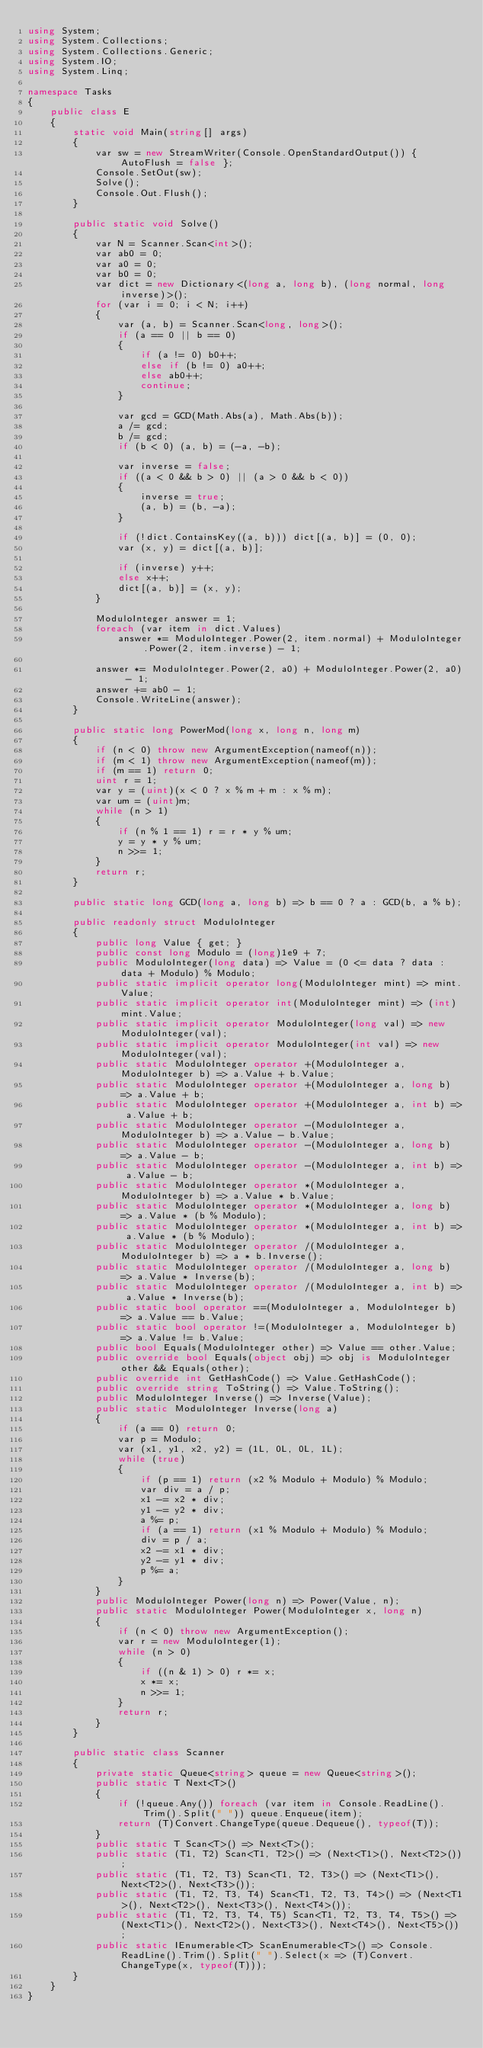Convert code to text. <code><loc_0><loc_0><loc_500><loc_500><_C#_>using System;
using System.Collections;
using System.Collections.Generic;
using System.IO;
using System.Linq;

namespace Tasks
{
    public class E
    {
        static void Main(string[] args)
        {
            var sw = new StreamWriter(Console.OpenStandardOutput()) { AutoFlush = false };
            Console.SetOut(sw);
            Solve();
            Console.Out.Flush();
        }

        public static void Solve()
        {
            var N = Scanner.Scan<int>();
            var ab0 = 0;
            var a0 = 0;
            var b0 = 0;
            var dict = new Dictionary<(long a, long b), (long normal, long inverse)>();
            for (var i = 0; i < N; i++)
            {
                var (a, b) = Scanner.Scan<long, long>();
                if (a == 0 || b == 0)
                {
                    if (a != 0) b0++;
                    else if (b != 0) a0++;
                    else ab0++;
                    continue;
                }

                var gcd = GCD(Math.Abs(a), Math.Abs(b));
                a /= gcd;
                b /= gcd;
                if (b < 0) (a, b) = (-a, -b);

                var inverse = false;
                if ((a < 0 && b > 0) || (a > 0 && b < 0))
                {
                    inverse = true;
                    (a, b) = (b, -a);
                }

                if (!dict.ContainsKey((a, b))) dict[(a, b)] = (0, 0);
                var (x, y) = dict[(a, b)];

                if (inverse) y++;
                else x++;
                dict[(a, b)] = (x, y);
            }

            ModuloInteger answer = 1;
            foreach (var item in dict.Values)
                answer *= ModuloInteger.Power(2, item.normal) + ModuloInteger.Power(2, item.inverse) - 1;

            answer *= ModuloInteger.Power(2, a0) + ModuloInteger.Power(2, a0) - 1;
            answer += ab0 - 1;
            Console.WriteLine(answer);
        }

        public static long PowerMod(long x, long n, long m)
        {
            if (n < 0) throw new ArgumentException(nameof(n));
            if (m < 1) throw new ArgumentException(nameof(m));
            if (m == 1) return 0;
            uint r = 1;
            var y = (uint)(x < 0 ? x % m + m : x % m);
            var um = (uint)m;
            while (n > 1)
            {
                if (n % 1 == 1) r = r * y % um;
                y = y * y % um;
                n >>= 1;
            }
            return r;
        }

        public static long GCD(long a, long b) => b == 0 ? a : GCD(b, a % b);

        public readonly struct ModuloInteger
        {
            public long Value { get; }
            public const long Modulo = (long)1e9 + 7;
            public ModuloInteger(long data) => Value = (0 <= data ? data : data + Modulo) % Modulo;
            public static implicit operator long(ModuloInteger mint) => mint.Value;
            public static implicit operator int(ModuloInteger mint) => (int)mint.Value;
            public static implicit operator ModuloInteger(long val) => new ModuloInteger(val);
            public static implicit operator ModuloInteger(int val) => new ModuloInteger(val);
            public static ModuloInteger operator +(ModuloInteger a, ModuloInteger b) => a.Value + b.Value;
            public static ModuloInteger operator +(ModuloInteger a, long b) => a.Value + b;
            public static ModuloInteger operator +(ModuloInteger a, int b) => a.Value + b;
            public static ModuloInteger operator -(ModuloInteger a, ModuloInteger b) => a.Value - b.Value;
            public static ModuloInteger operator -(ModuloInteger a, long b) => a.Value - b;
            public static ModuloInteger operator -(ModuloInteger a, int b) => a.Value - b;
            public static ModuloInteger operator *(ModuloInteger a, ModuloInteger b) => a.Value * b.Value;
            public static ModuloInteger operator *(ModuloInteger a, long b) => a.Value * (b % Modulo);
            public static ModuloInteger operator *(ModuloInteger a, int b) => a.Value * (b % Modulo);
            public static ModuloInteger operator /(ModuloInteger a, ModuloInteger b) => a * b.Inverse();
            public static ModuloInteger operator /(ModuloInteger a, long b) => a.Value * Inverse(b);
            public static ModuloInteger operator /(ModuloInteger a, int b) => a.Value * Inverse(b);
            public static bool operator ==(ModuloInteger a, ModuloInteger b) => a.Value == b.Value;
            public static bool operator !=(ModuloInteger a, ModuloInteger b) => a.Value != b.Value;
            public bool Equals(ModuloInteger other) => Value == other.Value;
            public override bool Equals(object obj) => obj is ModuloInteger other && Equals(other);
            public override int GetHashCode() => Value.GetHashCode();
            public override string ToString() => Value.ToString();
            public ModuloInteger Inverse() => Inverse(Value);
            public static ModuloInteger Inverse(long a)
            {
                if (a == 0) return 0;
                var p = Modulo;
                var (x1, y1, x2, y2) = (1L, 0L, 0L, 1L);
                while (true)
                {
                    if (p == 1) return (x2 % Modulo + Modulo) % Modulo;
                    var div = a / p;
                    x1 -= x2 * div;
                    y1 -= y2 * div;
                    a %= p;
                    if (a == 1) return (x1 % Modulo + Modulo) % Modulo;
                    div = p / a;
                    x2 -= x1 * div;
                    y2 -= y1 * div;
                    p %= a;
                }
            }
            public ModuloInteger Power(long n) => Power(Value, n);
            public static ModuloInteger Power(ModuloInteger x, long n)
            {
                if (n < 0) throw new ArgumentException();
                var r = new ModuloInteger(1);
                while (n > 0)
                {
                    if ((n & 1) > 0) r *= x;
                    x *= x;
                    n >>= 1;
                }
                return r;
            }
        }

        public static class Scanner
        {
            private static Queue<string> queue = new Queue<string>();
            public static T Next<T>()
            {
                if (!queue.Any()) foreach (var item in Console.ReadLine().Trim().Split(" ")) queue.Enqueue(item);
                return (T)Convert.ChangeType(queue.Dequeue(), typeof(T));
            }
            public static T Scan<T>() => Next<T>();
            public static (T1, T2) Scan<T1, T2>() => (Next<T1>(), Next<T2>());
            public static (T1, T2, T3) Scan<T1, T2, T3>() => (Next<T1>(), Next<T2>(), Next<T3>());
            public static (T1, T2, T3, T4) Scan<T1, T2, T3, T4>() => (Next<T1>(), Next<T2>(), Next<T3>(), Next<T4>());
            public static (T1, T2, T3, T4, T5) Scan<T1, T2, T3, T4, T5>() => (Next<T1>(), Next<T2>(), Next<T3>(), Next<T4>(), Next<T5>());
            public static IEnumerable<T> ScanEnumerable<T>() => Console.ReadLine().Trim().Split(" ").Select(x => (T)Convert.ChangeType(x, typeof(T)));
        }
    }
}
</code> 